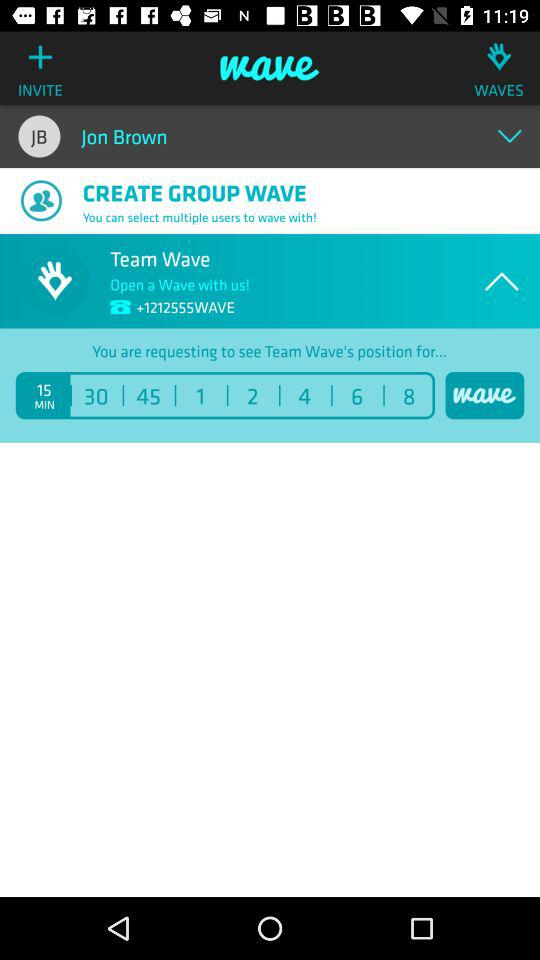How many minutes is the user requesting for? The user requesting for 15 minutes. 